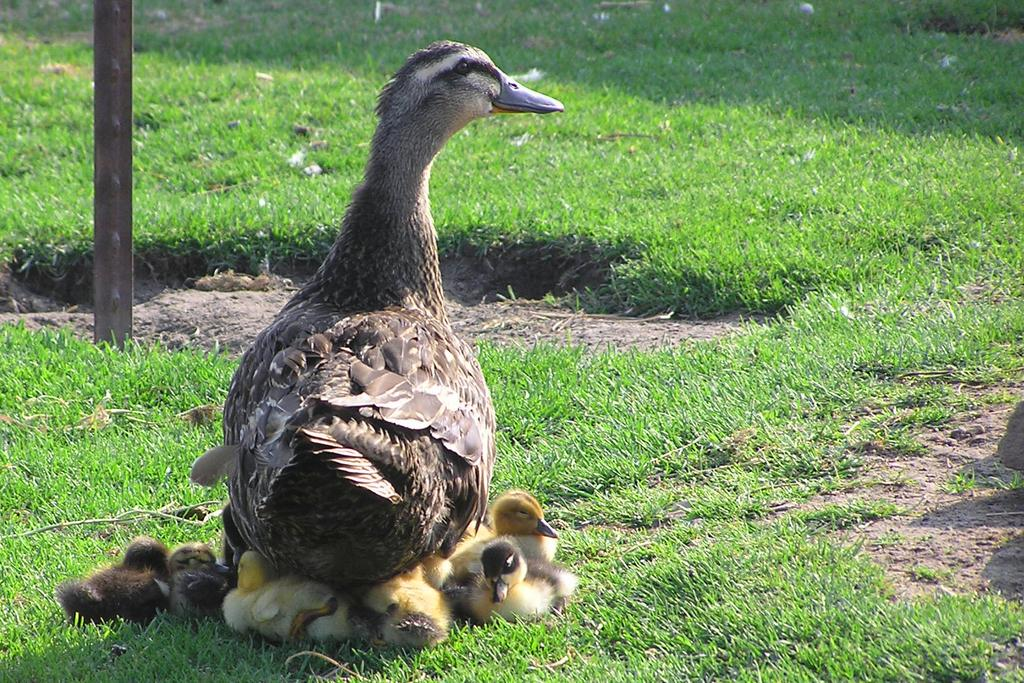What type of animal is in the image? There is a bird in the image. Can you describe the bird's appearance? The bird has brown, black, and white colors. Are there any other birds in the image? Yes, there are smaller birds in the image. What can be seen in the background of the image? There is grass and a pole visible in the background of the image. What type of news can be read on the bird's elbow in the image? There is no news or elbow present in the image; it features a bird and smaller birds in a grassy background with a pole. 